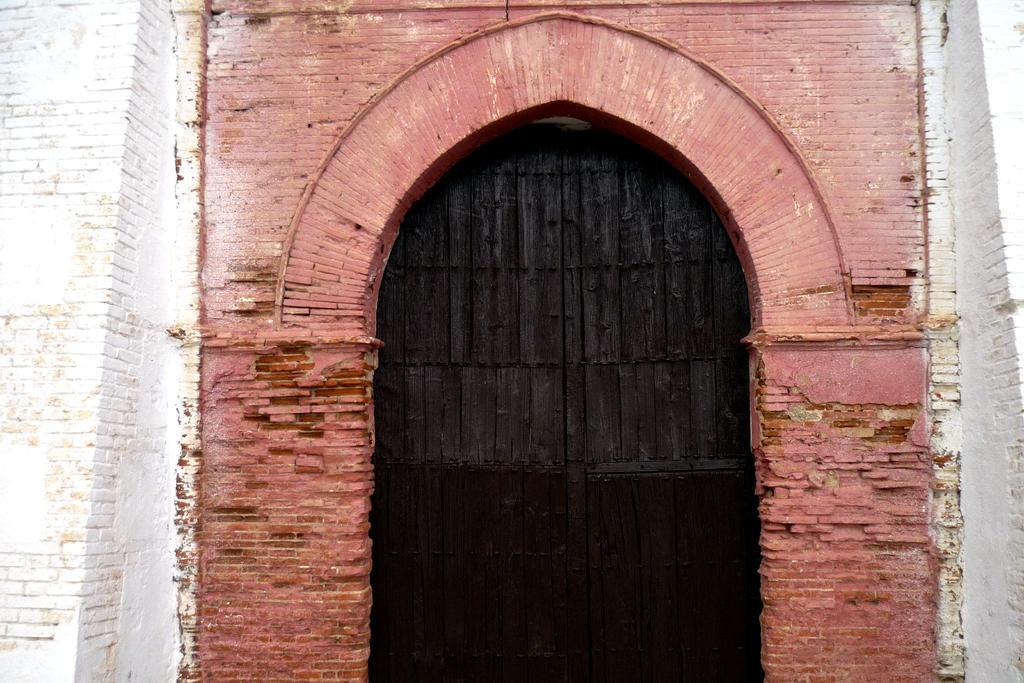Can you describe this image briefly? This is a picture of the building, where there is a wooden door. 